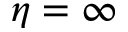<formula> <loc_0><loc_0><loc_500><loc_500>\eta = \infty</formula> 